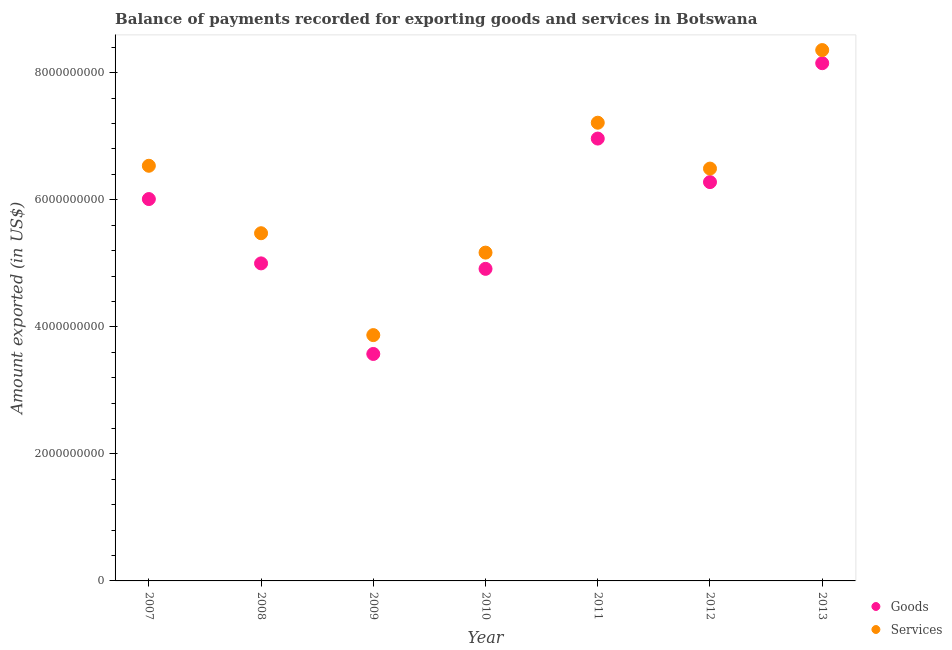How many different coloured dotlines are there?
Keep it short and to the point. 2. What is the amount of services exported in 2010?
Make the answer very short. 5.17e+09. Across all years, what is the maximum amount of goods exported?
Your answer should be very brief. 8.15e+09. Across all years, what is the minimum amount of services exported?
Ensure brevity in your answer.  3.87e+09. In which year was the amount of services exported maximum?
Your response must be concise. 2013. What is the total amount of services exported in the graph?
Offer a very short reply. 4.31e+1. What is the difference between the amount of services exported in 2010 and that in 2011?
Your response must be concise. -2.04e+09. What is the difference between the amount of goods exported in 2007 and the amount of services exported in 2013?
Your answer should be compact. -2.35e+09. What is the average amount of services exported per year?
Provide a short and direct response. 6.16e+09. In the year 2012, what is the difference between the amount of services exported and amount of goods exported?
Provide a succinct answer. 2.13e+08. In how many years, is the amount of services exported greater than 1600000000 US$?
Keep it short and to the point. 7. What is the ratio of the amount of goods exported in 2007 to that in 2012?
Your answer should be very brief. 0.96. Is the amount of goods exported in 2007 less than that in 2008?
Keep it short and to the point. No. Is the difference between the amount of services exported in 2007 and 2010 greater than the difference between the amount of goods exported in 2007 and 2010?
Your answer should be compact. Yes. What is the difference between the highest and the second highest amount of goods exported?
Offer a terse response. 1.19e+09. What is the difference between the highest and the lowest amount of goods exported?
Provide a short and direct response. 4.58e+09. Is the sum of the amount of services exported in 2007 and 2013 greater than the maximum amount of goods exported across all years?
Your answer should be very brief. Yes. What is the difference between two consecutive major ticks on the Y-axis?
Make the answer very short. 2.00e+09. Are the values on the major ticks of Y-axis written in scientific E-notation?
Ensure brevity in your answer.  No. Does the graph contain grids?
Provide a succinct answer. No. What is the title of the graph?
Provide a succinct answer. Balance of payments recorded for exporting goods and services in Botswana. What is the label or title of the Y-axis?
Your answer should be compact. Amount exported (in US$). What is the Amount exported (in US$) of Goods in 2007?
Give a very brief answer. 6.01e+09. What is the Amount exported (in US$) of Services in 2007?
Your answer should be compact. 6.54e+09. What is the Amount exported (in US$) in Goods in 2008?
Offer a very short reply. 5.00e+09. What is the Amount exported (in US$) in Services in 2008?
Your answer should be very brief. 5.47e+09. What is the Amount exported (in US$) of Goods in 2009?
Your answer should be very brief. 3.57e+09. What is the Amount exported (in US$) in Services in 2009?
Your response must be concise. 3.87e+09. What is the Amount exported (in US$) in Goods in 2010?
Offer a very short reply. 4.91e+09. What is the Amount exported (in US$) of Services in 2010?
Make the answer very short. 5.17e+09. What is the Amount exported (in US$) of Goods in 2011?
Give a very brief answer. 6.96e+09. What is the Amount exported (in US$) in Services in 2011?
Your answer should be very brief. 7.21e+09. What is the Amount exported (in US$) in Goods in 2012?
Your answer should be very brief. 6.28e+09. What is the Amount exported (in US$) of Services in 2012?
Provide a succinct answer. 6.49e+09. What is the Amount exported (in US$) of Goods in 2013?
Your answer should be compact. 8.15e+09. What is the Amount exported (in US$) in Services in 2013?
Your response must be concise. 8.36e+09. Across all years, what is the maximum Amount exported (in US$) of Goods?
Ensure brevity in your answer.  8.15e+09. Across all years, what is the maximum Amount exported (in US$) of Services?
Provide a short and direct response. 8.36e+09. Across all years, what is the minimum Amount exported (in US$) in Goods?
Make the answer very short. 3.57e+09. Across all years, what is the minimum Amount exported (in US$) of Services?
Make the answer very short. 3.87e+09. What is the total Amount exported (in US$) of Goods in the graph?
Offer a very short reply. 4.09e+1. What is the total Amount exported (in US$) in Services in the graph?
Give a very brief answer. 4.31e+1. What is the difference between the Amount exported (in US$) in Goods in 2007 and that in 2008?
Keep it short and to the point. 1.01e+09. What is the difference between the Amount exported (in US$) in Services in 2007 and that in 2008?
Ensure brevity in your answer.  1.06e+09. What is the difference between the Amount exported (in US$) of Goods in 2007 and that in 2009?
Your answer should be compact. 2.44e+09. What is the difference between the Amount exported (in US$) in Services in 2007 and that in 2009?
Your answer should be compact. 2.67e+09. What is the difference between the Amount exported (in US$) in Goods in 2007 and that in 2010?
Your answer should be very brief. 1.10e+09. What is the difference between the Amount exported (in US$) of Services in 2007 and that in 2010?
Offer a terse response. 1.37e+09. What is the difference between the Amount exported (in US$) of Goods in 2007 and that in 2011?
Give a very brief answer. -9.52e+08. What is the difference between the Amount exported (in US$) of Services in 2007 and that in 2011?
Your response must be concise. -6.78e+08. What is the difference between the Amount exported (in US$) in Goods in 2007 and that in 2012?
Your answer should be very brief. -2.67e+08. What is the difference between the Amount exported (in US$) of Services in 2007 and that in 2012?
Make the answer very short. 4.44e+07. What is the difference between the Amount exported (in US$) of Goods in 2007 and that in 2013?
Keep it short and to the point. -2.14e+09. What is the difference between the Amount exported (in US$) of Services in 2007 and that in 2013?
Make the answer very short. -1.82e+09. What is the difference between the Amount exported (in US$) of Goods in 2008 and that in 2009?
Your answer should be very brief. 1.43e+09. What is the difference between the Amount exported (in US$) in Services in 2008 and that in 2009?
Offer a very short reply. 1.60e+09. What is the difference between the Amount exported (in US$) in Goods in 2008 and that in 2010?
Provide a short and direct response. 8.60e+07. What is the difference between the Amount exported (in US$) in Services in 2008 and that in 2010?
Your response must be concise. 3.05e+08. What is the difference between the Amount exported (in US$) of Goods in 2008 and that in 2011?
Provide a short and direct response. -1.96e+09. What is the difference between the Amount exported (in US$) of Services in 2008 and that in 2011?
Give a very brief answer. -1.74e+09. What is the difference between the Amount exported (in US$) of Goods in 2008 and that in 2012?
Offer a terse response. -1.28e+09. What is the difference between the Amount exported (in US$) in Services in 2008 and that in 2012?
Offer a terse response. -1.02e+09. What is the difference between the Amount exported (in US$) of Goods in 2008 and that in 2013?
Keep it short and to the point. -3.15e+09. What is the difference between the Amount exported (in US$) in Services in 2008 and that in 2013?
Provide a short and direct response. -2.88e+09. What is the difference between the Amount exported (in US$) in Goods in 2009 and that in 2010?
Make the answer very short. -1.34e+09. What is the difference between the Amount exported (in US$) of Services in 2009 and that in 2010?
Provide a succinct answer. -1.30e+09. What is the difference between the Amount exported (in US$) in Goods in 2009 and that in 2011?
Ensure brevity in your answer.  -3.39e+09. What is the difference between the Amount exported (in US$) of Services in 2009 and that in 2011?
Make the answer very short. -3.34e+09. What is the difference between the Amount exported (in US$) of Goods in 2009 and that in 2012?
Your response must be concise. -2.71e+09. What is the difference between the Amount exported (in US$) of Services in 2009 and that in 2012?
Your answer should be very brief. -2.62e+09. What is the difference between the Amount exported (in US$) in Goods in 2009 and that in 2013?
Keep it short and to the point. -4.58e+09. What is the difference between the Amount exported (in US$) of Services in 2009 and that in 2013?
Make the answer very short. -4.49e+09. What is the difference between the Amount exported (in US$) of Goods in 2010 and that in 2011?
Provide a succinct answer. -2.05e+09. What is the difference between the Amount exported (in US$) of Services in 2010 and that in 2011?
Provide a short and direct response. -2.04e+09. What is the difference between the Amount exported (in US$) of Goods in 2010 and that in 2012?
Provide a short and direct response. -1.37e+09. What is the difference between the Amount exported (in US$) in Services in 2010 and that in 2012?
Keep it short and to the point. -1.32e+09. What is the difference between the Amount exported (in US$) of Goods in 2010 and that in 2013?
Your answer should be compact. -3.24e+09. What is the difference between the Amount exported (in US$) of Services in 2010 and that in 2013?
Your answer should be very brief. -3.19e+09. What is the difference between the Amount exported (in US$) of Goods in 2011 and that in 2012?
Your answer should be very brief. 6.85e+08. What is the difference between the Amount exported (in US$) in Services in 2011 and that in 2012?
Provide a succinct answer. 7.22e+08. What is the difference between the Amount exported (in US$) in Goods in 2011 and that in 2013?
Offer a terse response. -1.19e+09. What is the difference between the Amount exported (in US$) in Services in 2011 and that in 2013?
Provide a short and direct response. -1.14e+09. What is the difference between the Amount exported (in US$) of Goods in 2012 and that in 2013?
Your response must be concise. -1.87e+09. What is the difference between the Amount exported (in US$) of Services in 2012 and that in 2013?
Give a very brief answer. -1.87e+09. What is the difference between the Amount exported (in US$) in Goods in 2007 and the Amount exported (in US$) in Services in 2008?
Provide a succinct answer. 5.38e+08. What is the difference between the Amount exported (in US$) of Goods in 2007 and the Amount exported (in US$) of Services in 2009?
Your response must be concise. 2.14e+09. What is the difference between the Amount exported (in US$) of Goods in 2007 and the Amount exported (in US$) of Services in 2010?
Your response must be concise. 8.43e+08. What is the difference between the Amount exported (in US$) in Goods in 2007 and the Amount exported (in US$) in Services in 2011?
Keep it short and to the point. -1.20e+09. What is the difference between the Amount exported (in US$) of Goods in 2007 and the Amount exported (in US$) of Services in 2012?
Offer a very short reply. -4.80e+08. What is the difference between the Amount exported (in US$) of Goods in 2007 and the Amount exported (in US$) of Services in 2013?
Your answer should be very brief. -2.35e+09. What is the difference between the Amount exported (in US$) in Goods in 2008 and the Amount exported (in US$) in Services in 2009?
Make the answer very short. 1.13e+09. What is the difference between the Amount exported (in US$) of Goods in 2008 and the Amount exported (in US$) of Services in 2010?
Your answer should be compact. -1.70e+08. What is the difference between the Amount exported (in US$) of Goods in 2008 and the Amount exported (in US$) of Services in 2011?
Ensure brevity in your answer.  -2.21e+09. What is the difference between the Amount exported (in US$) of Goods in 2008 and the Amount exported (in US$) of Services in 2012?
Make the answer very short. -1.49e+09. What is the difference between the Amount exported (in US$) of Goods in 2008 and the Amount exported (in US$) of Services in 2013?
Offer a terse response. -3.36e+09. What is the difference between the Amount exported (in US$) in Goods in 2009 and the Amount exported (in US$) in Services in 2010?
Provide a short and direct response. -1.60e+09. What is the difference between the Amount exported (in US$) of Goods in 2009 and the Amount exported (in US$) of Services in 2011?
Your answer should be very brief. -3.64e+09. What is the difference between the Amount exported (in US$) of Goods in 2009 and the Amount exported (in US$) of Services in 2012?
Keep it short and to the point. -2.92e+09. What is the difference between the Amount exported (in US$) of Goods in 2009 and the Amount exported (in US$) of Services in 2013?
Keep it short and to the point. -4.78e+09. What is the difference between the Amount exported (in US$) in Goods in 2010 and the Amount exported (in US$) in Services in 2011?
Offer a terse response. -2.30e+09. What is the difference between the Amount exported (in US$) of Goods in 2010 and the Amount exported (in US$) of Services in 2012?
Offer a very short reply. -1.58e+09. What is the difference between the Amount exported (in US$) of Goods in 2010 and the Amount exported (in US$) of Services in 2013?
Your answer should be very brief. -3.44e+09. What is the difference between the Amount exported (in US$) in Goods in 2011 and the Amount exported (in US$) in Services in 2012?
Provide a succinct answer. 4.73e+08. What is the difference between the Amount exported (in US$) of Goods in 2011 and the Amount exported (in US$) of Services in 2013?
Make the answer very short. -1.39e+09. What is the difference between the Amount exported (in US$) in Goods in 2012 and the Amount exported (in US$) in Services in 2013?
Offer a terse response. -2.08e+09. What is the average Amount exported (in US$) of Goods per year?
Give a very brief answer. 5.84e+09. What is the average Amount exported (in US$) in Services per year?
Provide a succinct answer. 6.16e+09. In the year 2007, what is the difference between the Amount exported (in US$) in Goods and Amount exported (in US$) in Services?
Provide a short and direct response. -5.24e+08. In the year 2008, what is the difference between the Amount exported (in US$) in Goods and Amount exported (in US$) in Services?
Your answer should be very brief. -4.75e+08. In the year 2009, what is the difference between the Amount exported (in US$) in Goods and Amount exported (in US$) in Services?
Make the answer very short. -2.97e+08. In the year 2010, what is the difference between the Amount exported (in US$) in Goods and Amount exported (in US$) in Services?
Make the answer very short. -2.56e+08. In the year 2011, what is the difference between the Amount exported (in US$) in Goods and Amount exported (in US$) in Services?
Ensure brevity in your answer.  -2.50e+08. In the year 2012, what is the difference between the Amount exported (in US$) of Goods and Amount exported (in US$) of Services?
Provide a short and direct response. -2.13e+08. In the year 2013, what is the difference between the Amount exported (in US$) of Goods and Amount exported (in US$) of Services?
Provide a short and direct response. -2.07e+08. What is the ratio of the Amount exported (in US$) of Goods in 2007 to that in 2008?
Your answer should be compact. 1.2. What is the ratio of the Amount exported (in US$) of Services in 2007 to that in 2008?
Make the answer very short. 1.19. What is the ratio of the Amount exported (in US$) in Goods in 2007 to that in 2009?
Ensure brevity in your answer.  1.68. What is the ratio of the Amount exported (in US$) in Services in 2007 to that in 2009?
Offer a terse response. 1.69. What is the ratio of the Amount exported (in US$) in Goods in 2007 to that in 2010?
Provide a succinct answer. 1.22. What is the ratio of the Amount exported (in US$) in Services in 2007 to that in 2010?
Make the answer very short. 1.26. What is the ratio of the Amount exported (in US$) in Goods in 2007 to that in 2011?
Your answer should be compact. 0.86. What is the ratio of the Amount exported (in US$) in Services in 2007 to that in 2011?
Ensure brevity in your answer.  0.91. What is the ratio of the Amount exported (in US$) of Goods in 2007 to that in 2012?
Your response must be concise. 0.96. What is the ratio of the Amount exported (in US$) of Services in 2007 to that in 2012?
Your answer should be compact. 1.01. What is the ratio of the Amount exported (in US$) of Goods in 2007 to that in 2013?
Give a very brief answer. 0.74. What is the ratio of the Amount exported (in US$) of Services in 2007 to that in 2013?
Give a very brief answer. 0.78. What is the ratio of the Amount exported (in US$) of Goods in 2008 to that in 2009?
Your answer should be very brief. 1.4. What is the ratio of the Amount exported (in US$) of Services in 2008 to that in 2009?
Ensure brevity in your answer.  1.41. What is the ratio of the Amount exported (in US$) in Goods in 2008 to that in 2010?
Make the answer very short. 1.02. What is the ratio of the Amount exported (in US$) in Services in 2008 to that in 2010?
Your answer should be compact. 1.06. What is the ratio of the Amount exported (in US$) of Goods in 2008 to that in 2011?
Your answer should be compact. 0.72. What is the ratio of the Amount exported (in US$) of Services in 2008 to that in 2011?
Provide a succinct answer. 0.76. What is the ratio of the Amount exported (in US$) in Goods in 2008 to that in 2012?
Your response must be concise. 0.8. What is the ratio of the Amount exported (in US$) in Services in 2008 to that in 2012?
Your response must be concise. 0.84. What is the ratio of the Amount exported (in US$) of Goods in 2008 to that in 2013?
Your answer should be compact. 0.61. What is the ratio of the Amount exported (in US$) in Services in 2008 to that in 2013?
Your response must be concise. 0.66. What is the ratio of the Amount exported (in US$) of Goods in 2009 to that in 2010?
Provide a succinct answer. 0.73. What is the ratio of the Amount exported (in US$) of Services in 2009 to that in 2010?
Keep it short and to the point. 0.75. What is the ratio of the Amount exported (in US$) in Goods in 2009 to that in 2011?
Your response must be concise. 0.51. What is the ratio of the Amount exported (in US$) in Services in 2009 to that in 2011?
Offer a terse response. 0.54. What is the ratio of the Amount exported (in US$) of Goods in 2009 to that in 2012?
Your answer should be compact. 0.57. What is the ratio of the Amount exported (in US$) of Services in 2009 to that in 2012?
Your answer should be compact. 0.6. What is the ratio of the Amount exported (in US$) of Goods in 2009 to that in 2013?
Offer a very short reply. 0.44. What is the ratio of the Amount exported (in US$) in Services in 2009 to that in 2013?
Ensure brevity in your answer.  0.46. What is the ratio of the Amount exported (in US$) in Goods in 2010 to that in 2011?
Give a very brief answer. 0.71. What is the ratio of the Amount exported (in US$) of Services in 2010 to that in 2011?
Keep it short and to the point. 0.72. What is the ratio of the Amount exported (in US$) in Goods in 2010 to that in 2012?
Offer a terse response. 0.78. What is the ratio of the Amount exported (in US$) in Services in 2010 to that in 2012?
Keep it short and to the point. 0.8. What is the ratio of the Amount exported (in US$) in Goods in 2010 to that in 2013?
Your answer should be very brief. 0.6. What is the ratio of the Amount exported (in US$) in Services in 2010 to that in 2013?
Offer a terse response. 0.62. What is the ratio of the Amount exported (in US$) of Goods in 2011 to that in 2012?
Your response must be concise. 1.11. What is the ratio of the Amount exported (in US$) in Services in 2011 to that in 2012?
Offer a terse response. 1.11. What is the ratio of the Amount exported (in US$) in Goods in 2011 to that in 2013?
Give a very brief answer. 0.85. What is the ratio of the Amount exported (in US$) in Services in 2011 to that in 2013?
Ensure brevity in your answer.  0.86. What is the ratio of the Amount exported (in US$) in Goods in 2012 to that in 2013?
Make the answer very short. 0.77. What is the ratio of the Amount exported (in US$) in Services in 2012 to that in 2013?
Provide a succinct answer. 0.78. What is the difference between the highest and the second highest Amount exported (in US$) of Goods?
Provide a short and direct response. 1.19e+09. What is the difference between the highest and the second highest Amount exported (in US$) of Services?
Offer a terse response. 1.14e+09. What is the difference between the highest and the lowest Amount exported (in US$) of Goods?
Your response must be concise. 4.58e+09. What is the difference between the highest and the lowest Amount exported (in US$) of Services?
Provide a short and direct response. 4.49e+09. 